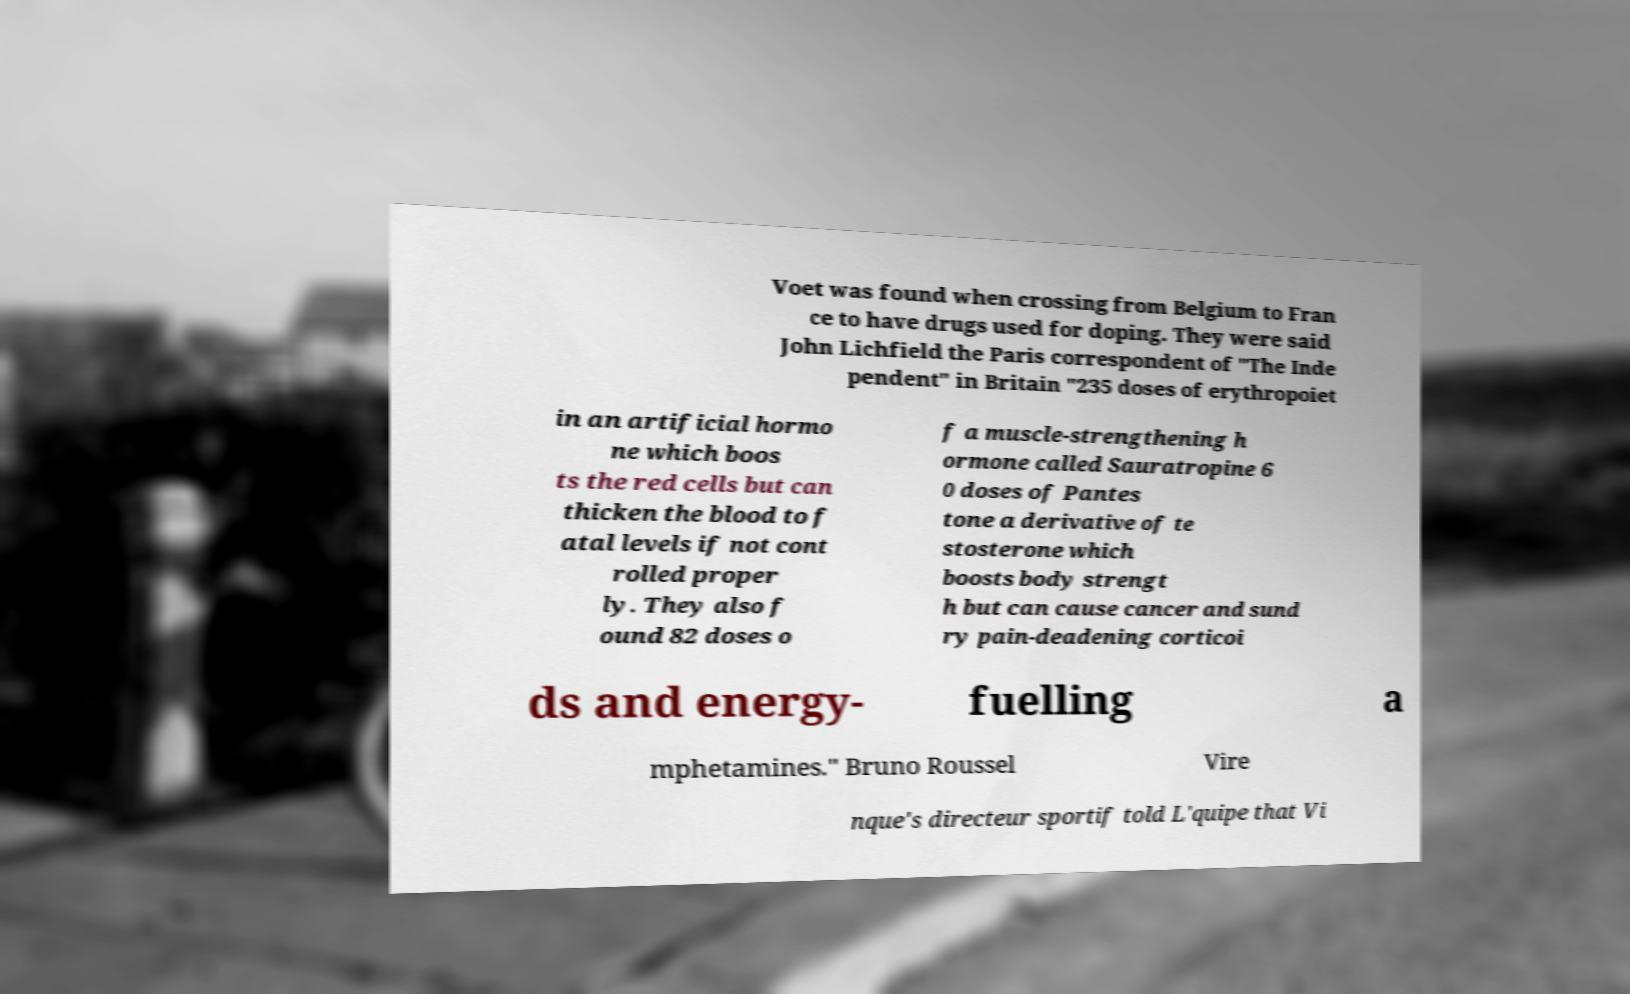Please identify and transcribe the text found in this image. Voet was found when crossing from Belgium to Fran ce to have drugs used for doping. They were said John Lichfield the Paris correspondent of "The Inde pendent" in Britain "235 doses of erythropoiet in an artificial hormo ne which boos ts the red cells but can thicken the blood to f atal levels if not cont rolled proper ly. They also f ound 82 doses o f a muscle-strengthening h ormone called Sauratropine 6 0 doses of Pantes tone a derivative of te stosterone which boosts body strengt h but can cause cancer and sund ry pain-deadening corticoi ds and energy- fuelling a mphetamines." Bruno Roussel Vire nque's directeur sportif told L'quipe that Vi 